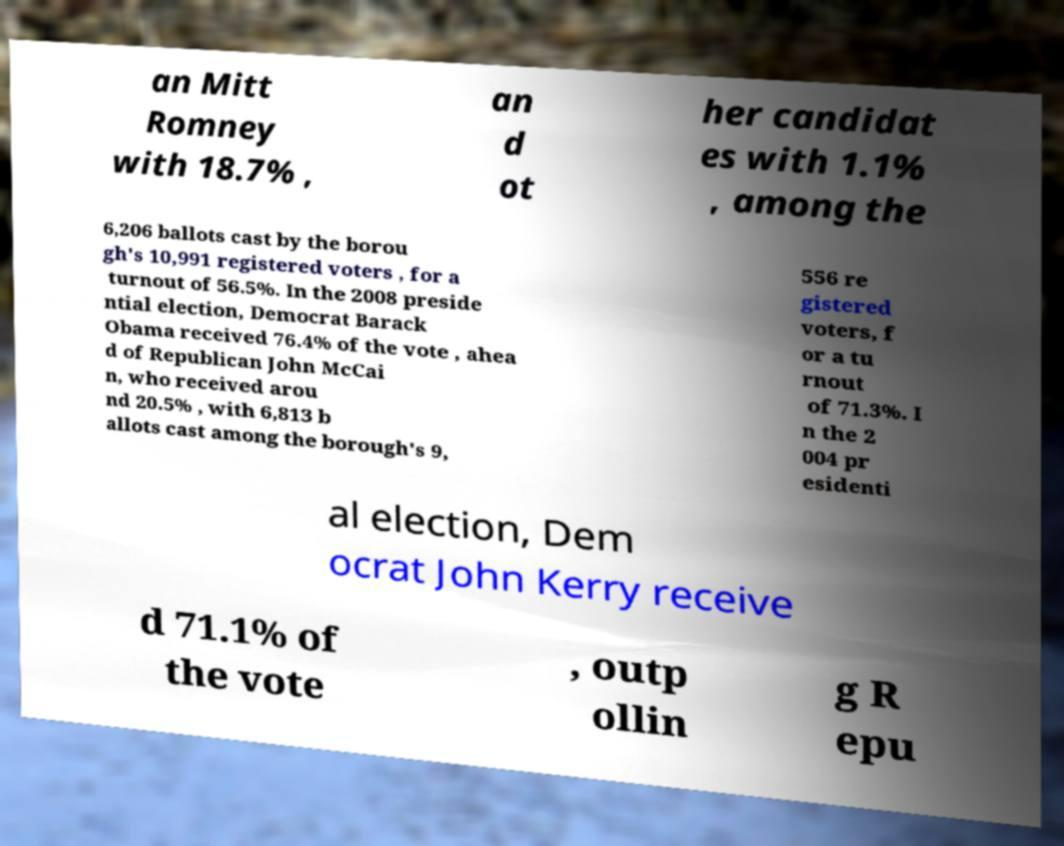Can you read and provide the text displayed in the image?This photo seems to have some interesting text. Can you extract and type it out for me? an Mitt Romney with 18.7% , an d ot her candidat es with 1.1% , among the 6,206 ballots cast by the borou gh's 10,991 registered voters , for a turnout of 56.5%. In the 2008 preside ntial election, Democrat Barack Obama received 76.4% of the vote , ahea d of Republican John McCai n, who received arou nd 20.5% , with 6,813 b allots cast among the borough's 9, 556 re gistered voters, f or a tu rnout of 71.3%. I n the 2 004 pr esidenti al election, Dem ocrat John Kerry receive d 71.1% of the vote , outp ollin g R epu 